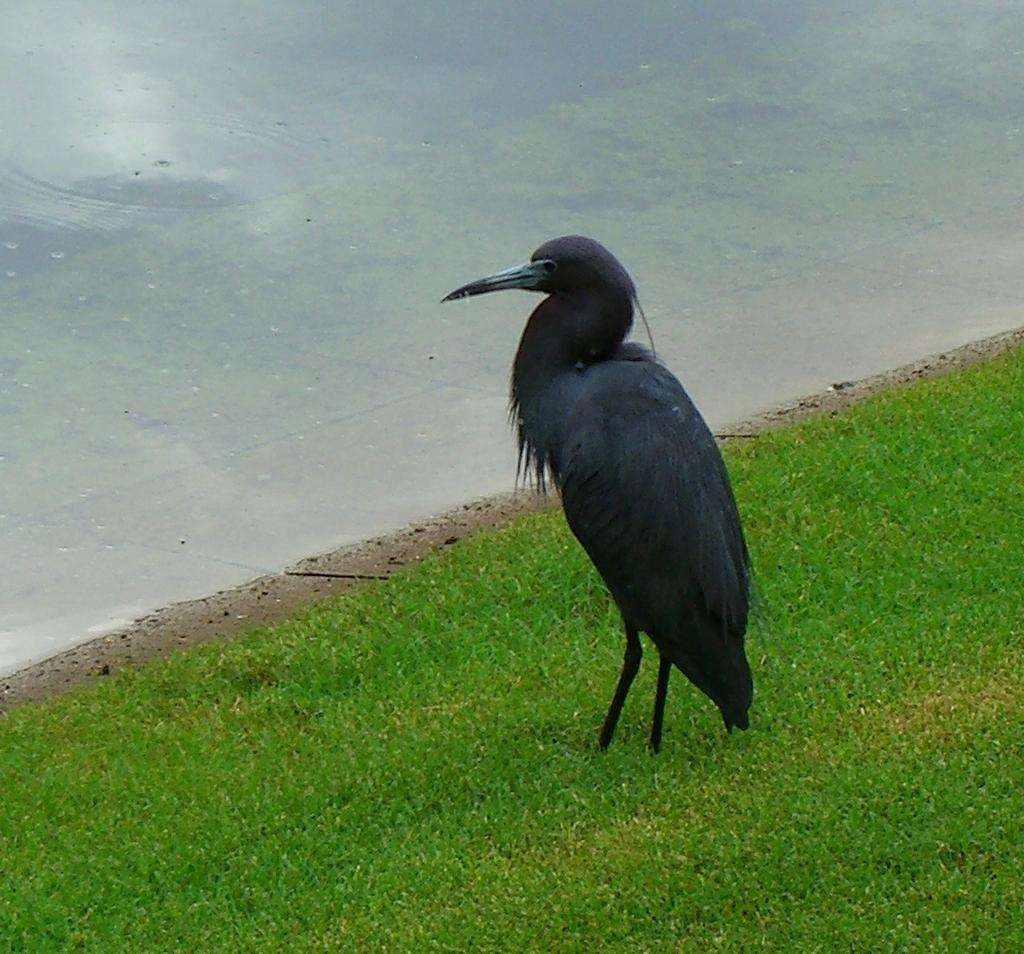What type of animal is present in the image? There is a bird in the image. Where is the bird located? The bird is on a grass field. What can be seen in the background of the image? There is water visible at the top of the image. Can you see a zipper on the bird in the image? There is no zipper present on the bird in the image. Where is the nearest market to the location of the bird in the image? The provided facts do not give any information about the location of a market, so it cannot be determined from the image. 